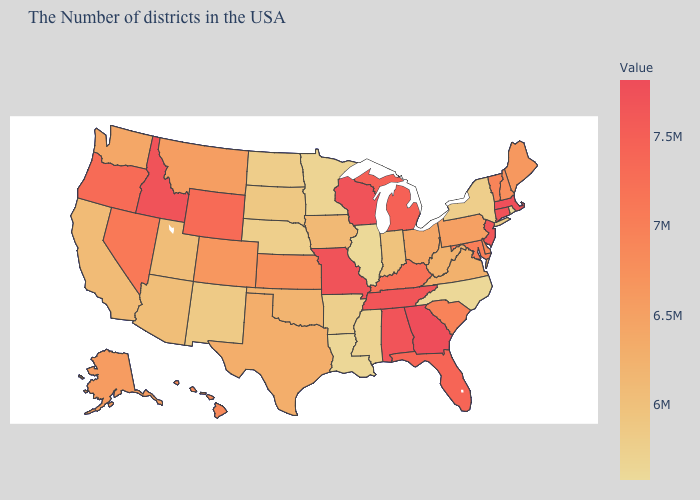Does Massachusetts have the highest value in the Northeast?
Concise answer only. Yes. Is the legend a continuous bar?
Short answer required. Yes. 